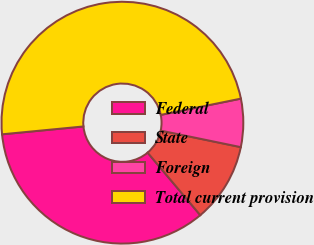<chart> <loc_0><loc_0><loc_500><loc_500><pie_chart><fcel>Federal<fcel>State<fcel>Foreign<fcel>Total current provision<nl><fcel>34.61%<fcel>10.62%<fcel>6.43%<fcel>48.35%<nl></chart> 